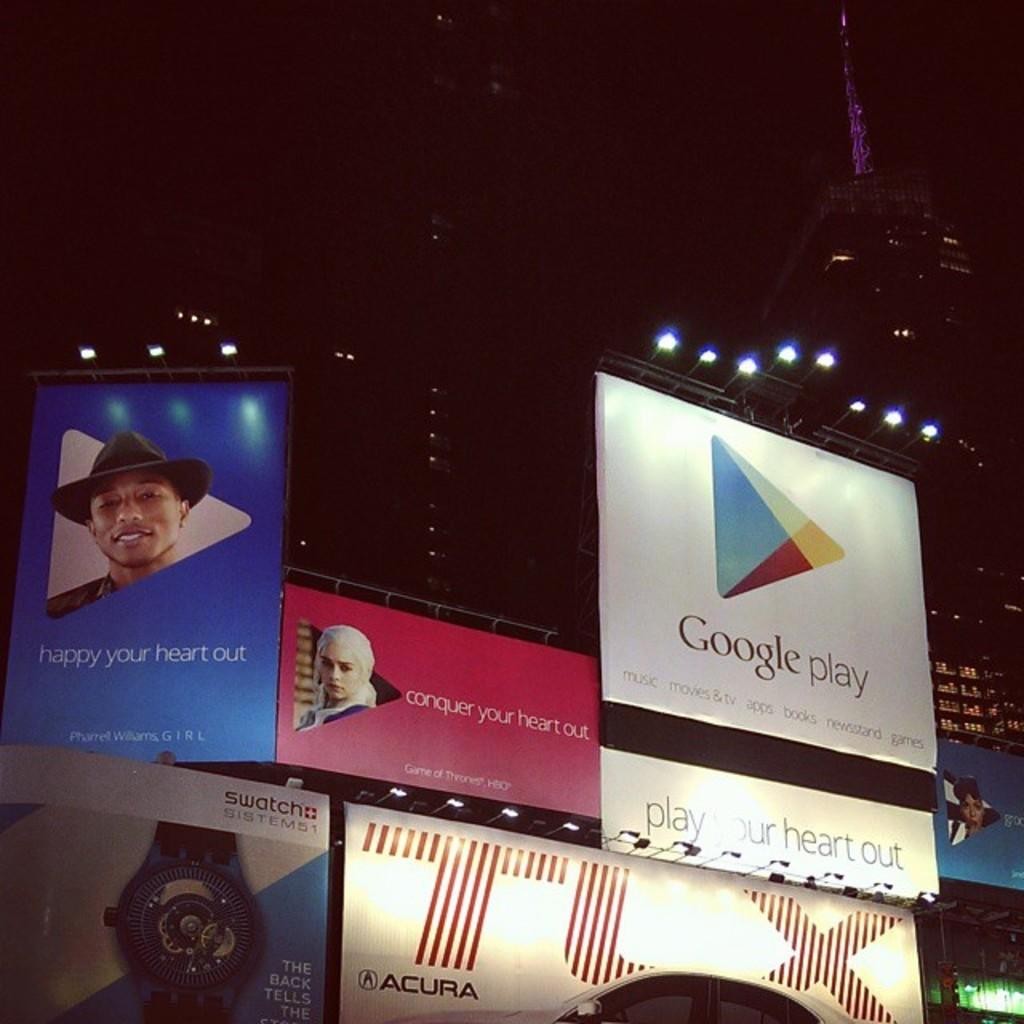<image>
Write a terse but informative summary of the picture. Several ads are sitting next to each other for different companies like google play and Acura. 